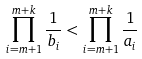<formula> <loc_0><loc_0><loc_500><loc_500>\prod _ { i = m + 1 } ^ { m + k } \frac { 1 } { b _ { i } } < \prod _ { i = m + 1 } ^ { m + k } \frac { 1 } { a _ { i } }</formula> 